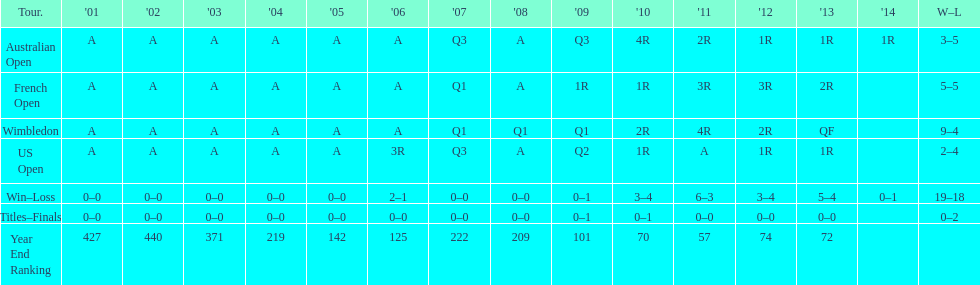In which years were there only 1 loss? 2006, 2009, 2014. 